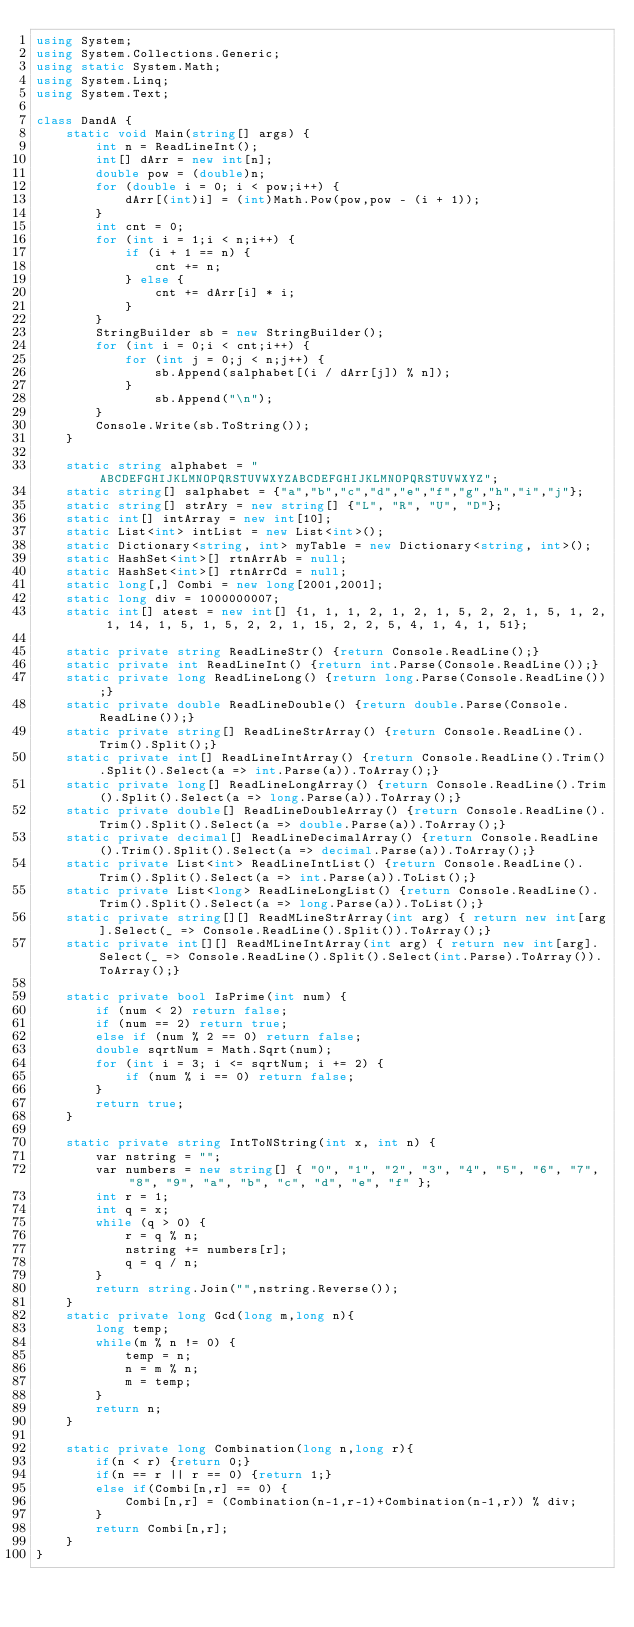<code> <loc_0><loc_0><loc_500><loc_500><_C#_>using System;
using System.Collections.Generic;
using static System.Math;
using System.Linq;
using System.Text;
 
class DandA {
    static void Main(string[] args) {
        int n = ReadLineInt();
        int[] dArr = new int[n];
        double pow = (double)n;
        for (double i = 0; i < pow;i++) {
            dArr[(int)i] = (int)Math.Pow(pow,pow - (i + 1));
        }
        int cnt = 0;
        for (int i = 1;i < n;i++) {
            if (i + 1 == n) {
                cnt += n;
            } else {
                cnt += dArr[i] * i;
            }
        }
        StringBuilder sb = new StringBuilder();
        for (int i = 0;i < cnt;i++) {
            for (int j = 0;j < n;j++) {
                sb.Append(salphabet[(i / dArr[j]) % n]);
            }
                sb.Append("\n");
        }
        Console.Write(sb.ToString());
    }
 
    static string alphabet = "ABCDEFGHIJKLMNOPQRSTUVWXYZABCDEFGHIJKLMNOPQRSTUVWXYZ";
    static string[] salphabet = {"a","b","c","d","e","f","g","h","i","j"};
    static string[] strAry = new string[] {"L", "R", "U", "D"};
    static int[] intArray = new int[10];
    static List<int> intList = new List<int>();
    static Dictionary<string, int> myTable = new Dictionary<string, int>();
    static HashSet<int>[] rtnArrAb = null;
    static HashSet<int>[] rtnArrCd = null;
    static long[,] Combi = new long[2001,2001];
    static long div = 1000000007;
    static int[] atest = new int[] {1, 1, 1, 2, 1, 2, 1, 5, 2, 2, 1, 5, 1, 2, 1, 14, 1, 5, 1, 5, 2, 2, 1, 15, 2, 2, 5, 4, 1, 4, 1, 51};
  
    static private string ReadLineStr() {return Console.ReadLine();}
    static private int ReadLineInt() {return int.Parse(Console.ReadLine());}
    static private long ReadLineLong() {return long.Parse(Console.ReadLine());}
    static private double ReadLineDouble() {return double.Parse(Console.ReadLine());}
    static private string[] ReadLineStrArray() {return Console.ReadLine().Trim().Split();}
    static private int[] ReadLineIntArray() {return Console.ReadLine().Trim().Split().Select(a => int.Parse(a)).ToArray();}
    static private long[] ReadLineLongArray() {return Console.ReadLine().Trim().Split().Select(a => long.Parse(a)).ToArray();}
    static private double[] ReadLineDoubleArray() {return Console.ReadLine().Trim().Split().Select(a => double.Parse(a)).ToArray();}
    static private decimal[] ReadLineDecimalArray() {return Console.ReadLine().Trim().Split().Select(a => decimal.Parse(a)).ToArray();}
    static private List<int> ReadLineIntList() {return Console.ReadLine().Trim().Split().Select(a => int.Parse(a)).ToList();}
    static private List<long> ReadLineLongList() {return Console.ReadLine().Trim().Split().Select(a => long.Parse(a)).ToList();}
    static private string[][] ReadMLineStrArray(int arg) { return new int[arg].Select(_ => Console.ReadLine().Split()).ToArray();}
    static private int[][] ReadMLineIntArray(int arg) { return new int[arg].Select(_ => Console.ReadLine().Split().Select(int.Parse).ToArray()).ToArray();}
 
    static private bool IsPrime(int num) {
        if (num < 2) return false;
        if (num == 2) return true;
        else if (num % 2 == 0) return false;
        double sqrtNum = Math.Sqrt(num);
        for (int i = 3; i <= sqrtNum; i += 2) {
            if (num % i == 0) return false;
        }
        return true;
    }
  
    static private string IntToNString(int x, int n) {
        var nstring = "";
        var numbers = new string[] { "0", "1", "2", "3", "4", "5", "6", "7", "8", "9", "a", "b", "c", "d", "e", "f" };
        int r = 1;
        int q = x;
        while (q > 0) {
            r = q % n;
            nstring += numbers[r];
            q = q / n;
        }
        return string.Join("",nstring.Reverse());
    }
    static private long Gcd(long m,long n){
        long temp;
        while(m % n != 0) {
            temp = n;
            n = m % n;
            m = temp;
        }
        return n;
    }
 
    static private long Combination(long n,long r){
        if(n < r) {return 0;}
        if(n == r || r == 0) {return 1;}
        else if(Combi[n,r] == 0) {
            Combi[n,r] = (Combination(n-1,r-1)+Combination(n-1,r)) % div;
        }
        return Combi[n,r];
    }
}</code> 